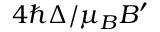<formula> <loc_0><loc_0><loc_500><loc_500>4 \hbar { \Delta } / \mu _ { B } B ^ { \prime }</formula> 